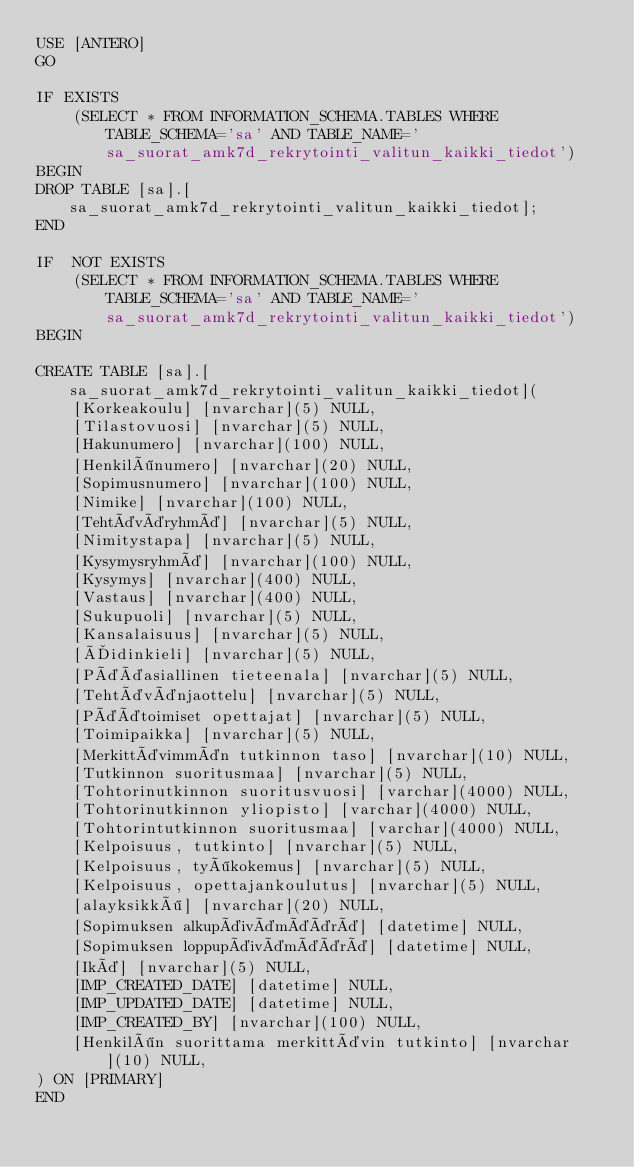<code> <loc_0><loc_0><loc_500><loc_500><_SQL_>USE [ANTERO]
GO

IF EXISTS
	(SELECT * FROM INFORMATION_SCHEMA.TABLES WHERE TABLE_SCHEMA='sa' AND TABLE_NAME='sa_suorat_amk7d_rekrytointi_valitun_kaikki_tiedot')
BEGIN
DROP TABLE [sa].[sa_suorat_amk7d_rekrytointi_valitun_kaikki_tiedot];
END

IF  NOT EXISTS
	(SELECT * FROM INFORMATION_SCHEMA.TABLES WHERE TABLE_SCHEMA='sa' AND TABLE_NAME='sa_suorat_amk7d_rekrytointi_valitun_kaikki_tiedot')
BEGIN

CREATE TABLE [sa].[sa_suorat_amk7d_rekrytointi_valitun_kaikki_tiedot](
	[Korkeakoulu] [nvarchar](5) NULL,
	[Tilastovuosi] [nvarchar](5) NULL,
	[Hakunumero] [nvarchar](100) NULL,
	[Henkilönumero] [nvarchar](20) NULL,
	[Sopimusnumero] [nvarchar](100) NULL,
	[Nimike] [nvarchar](100) NULL,
	[Tehtäväryhmä] [nvarchar](5) NULL,
	[Nimitystapa] [nvarchar](5) NULL,
	[Kysymysryhmä] [nvarchar](100) NULL,
	[Kysymys] [nvarchar](400) NULL,
	[Vastaus] [nvarchar](400) NULL,
	[Sukupuoli] [nvarchar](5) NULL,
	[Kansalaisuus] [nvarchar](5) NULL,
	[Äidinkieli] [nvarchar](5) NULL,
	[Pääasiallinen tieteenala] [nvarchar](5) NULL,
	[Tehtävänjaottelu] [nvarchar](5) NULL,
	[Päätoimiset opettajat] [nvarchar](5) NULL,
	[Toimipaikka] [nvarchar](5) NULL,
	[Merkittävimmän tutkinnon taso] [nvarchar](10) NULL,
	[Tutkinnon suoritusmaa] [nvarchar](5) NULL,
	[Tohtorinutkinnon suoritusvuosi] [varchar](4000) NULL,
	[Tohtorinutkinnon yliopisto] [varchar](4000) NULL,
	[Tohtorintutkinnon suoritusmaa] [varchar](4000) NULL,
	[Kelpoisuus, tutkinto] [nvarchar](5) NULL,
	[Kelpoisuus, työkokemus] [nvarchar](5) NULL,
	[Kelpoisuus, opettajankoulutus] [nvarchar](5) NULL,
	[alayksikkö] [nvarchar](20) NULL,
	[Sopimuksen alkupäivämäärä] [datetime] NULL,
	[Sopimuksen loppupäivämäärä] [datetime] NULL,
	[Ikä] [nvarchar](5) NULL,
	[IMP_CREATED_DATE] [datetime] NULL,
	[IMP_UPDATED_DATE] [datetime] NULL,
	[IMP_CREATED_BY] [nvarchar](100) NULL,
	[Henkilön suorittama merkittävin tutkinto] [nvarchar](10) NULL,
) ON [PRIMARY]
END
</code> 